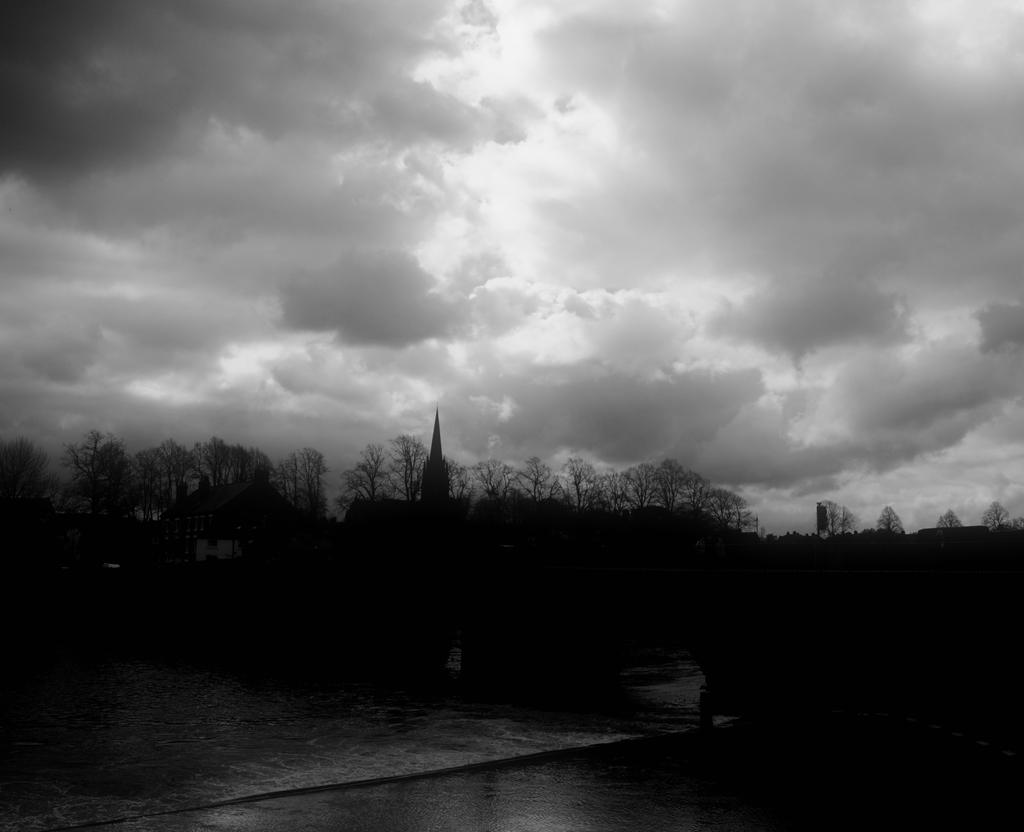What type of vegetation can be seen in the image? There are trees in the image. What natural element is visible in the image besides the trees? There is water visible in the image. What is the condition of the sky in the image? The sky is cloudy in the image. How many chairs can be seen floating on the water in the image? There are no chairs visible in the image. 